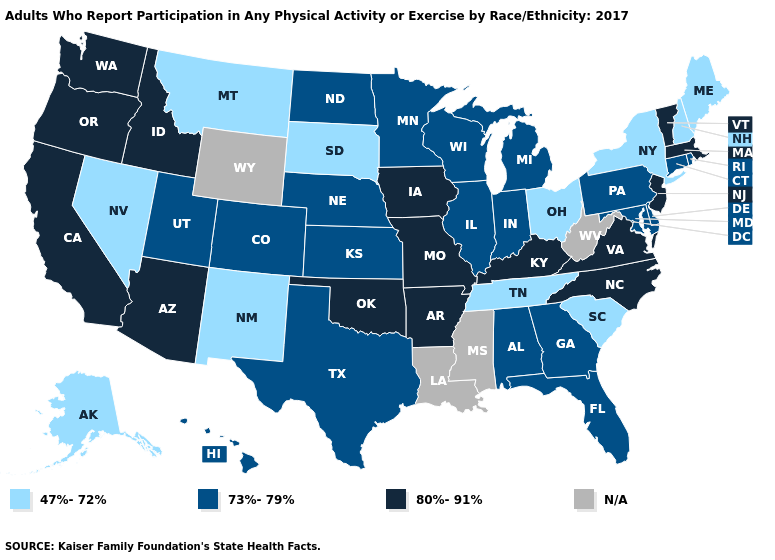What is the value of Michigan?
Short answer required. 73%-79%. Does Massachusetts have the lowest value in the Northeast?
Concise answer only. No. What is the lowest value in states that border Connecticut?
Give a very brief answer. 47%-72%. What is the highest value in the South ?
Short answer required. 80%-91%. Which states hav the highest value in the West?
Be succinct. Arizona, California, Idaho, Oregon, Washington. Name the states that have a value in the range 80%-91%?
Be succinct. Arizona, Arkansas, California, Idaho, Iowa, Kentucky, Massachusetts, Missouri, New Jersey, North Carolina, Oklahoma, Oregon, Vermont, Virginia, Washington. What is the highest value in the USA?
Write a very short answer. 80%-91%. Does Idaho have the highest value in the West?
Write a very short answer. Yes. Name the states that have a value in the range 80%-91%?
Short answer required. Arizona, Arkansas, California, Idaho, Iowa, Kentucky, Massachusetts, Missouri, New Jersey, North Carolina, Oklahoma, Oregon, Vermont, Virginia, Washington. Does South Dakota have the lowest value in the MidWest?
Give a very brief answer. Yes. Name the states that have a value in the range 73%-79%?
Concise answer only. Alabama, Colorado, Connecticut, Delaware, Florida, Georgia, Hawaii, Illinois, Indiana, Kansas, Maryland, Michigan, Minnesota, Nebraska, North Dakota, Pennsylvania, Rhode Island, Texas, Utah, Wisconsin. Name the states that have a value in the range 80%-91%?
Write a very short answer. Arizona, Arkansas, California, Idaho, Iowa, Kentucky, Massachusetts, Missouri, New Jersey, North Carolina, Oklahoma, Oregon, Vermont, Virginia, Washington. Which states have the lowest value in the USA?
Quick response, please. Alaska, Maine, Montana, Nevada, New Hampshire, New Mexico, New York, Ohio, South Carolina, South Dakota, Tennessee. Name the states that have a value in the range 73%-79%?
Be succinct. Alabama, Colorado, Connecticut, Delaware, Florida, Georgia, Hawaii, Illinois, Indiana, Kansas, Maryland, Michigan, Minnesota, Nebraska, North Dakota, Pennsylvania, Rhode Island, Texas, Utah, Wisconsin. 